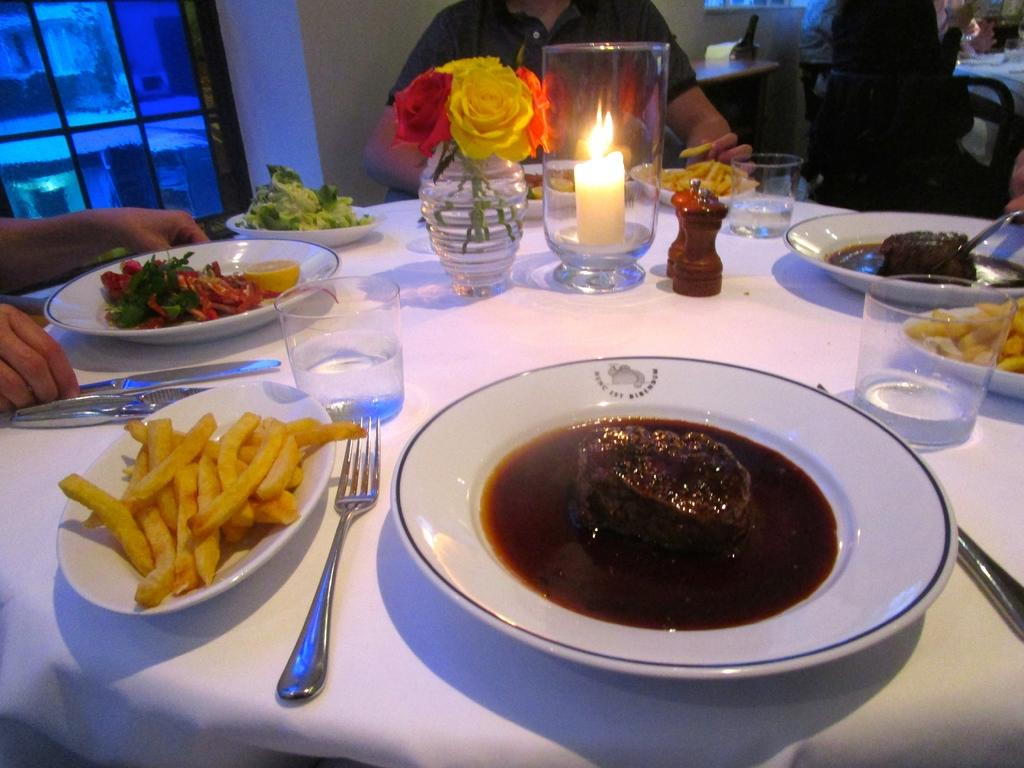How many people are in the image? There are people in the image, but the exact number is not specified. What are the people doing in the image? The people are sitting on chairs in the image. What objects can be seen in the image related to decoration? There are flower vases in the image. What objects can be seen in the image related to lighting? There is a candle in the image. What objects can be seen in the image related to dining? There are glasses, forks, knives, and food on plates in the image. How many cherries are on the table in the image? There is no mention of cherries in the image, so we cannot determine the number of cherries. What suggestion is being made by the people in the image? There is no indication of a suggestion being made in the image. 